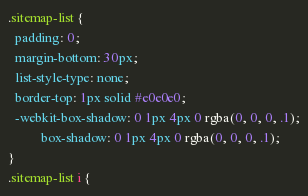<code> <loc_0><loc_0><loc_500><loc_500><_CSS_>.sitemap-list {
  padding: 0;
  margin-bottom: 30px;
  list-style-type: none;
  border-top: 1px solid #e0e0e0;
  -webkit-box-shadow: 0 1px 4px 0 rgba(0, 0, 0, .1);
          box-shadow: 0 1px 4px 0 rgba(0, 0, 0, .1);
}
.sitemap-list i {</code> 